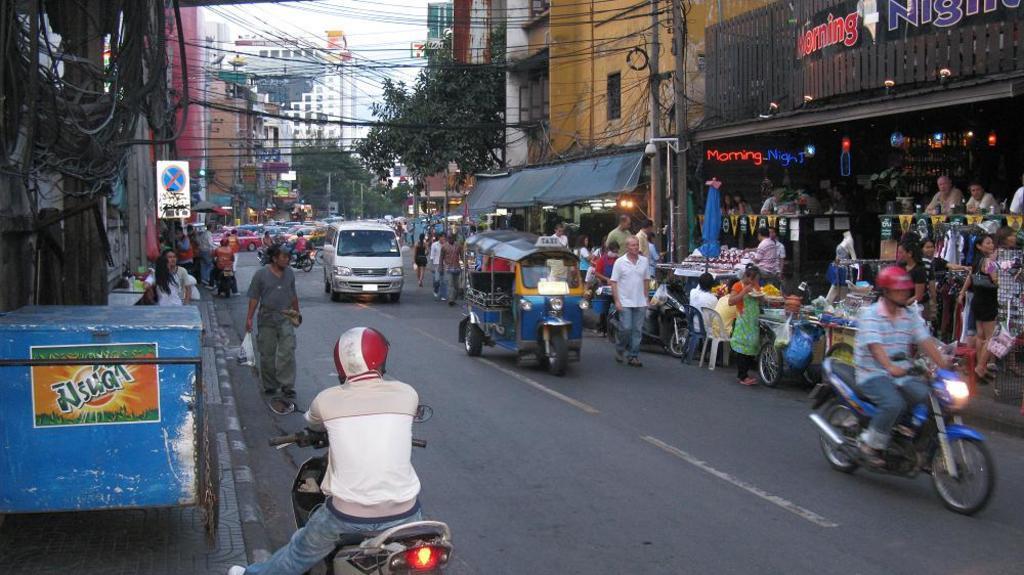In one or two sentences, can you explain what this image depicts? Some vehicles are passing on a road. There are some people walking on a footpath. There is a store beside the road. There are some buildings and cables across in the background. 